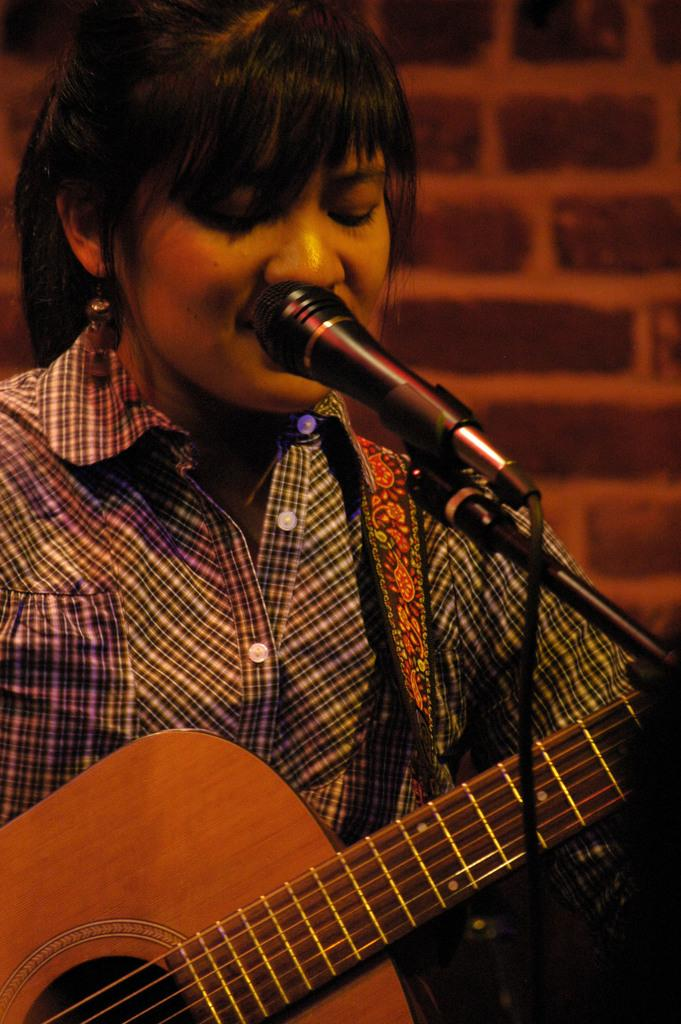What is the person in the image holding? The person is holding a guitar in the image. What object is in front of the person? There is a microphone in front of the person. What type of wall can be seen in the background of the image? There is a wall made of bricks in the background of the image. What type of hose is being used to play the guitar in the image? There is no hose present in the image, and the guitar is not being played with a hose. 